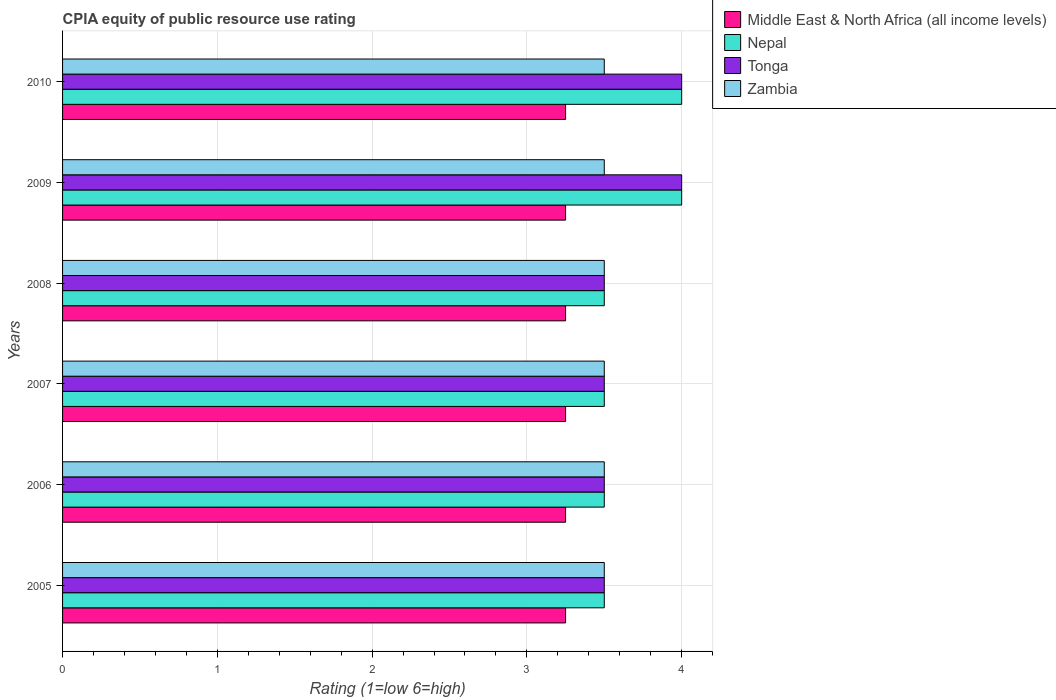How many groups of bars are there?
Provide a short and direct response. 6. Are the number of bars on each tick of the Y-axis equal?
Offer a terse response. Yes. How many bars are there on the 5th tick from the bottom?
Make the answer very short. 4. What is the label of the 3rd group of bars from the top?
Ensure brevity in your answer.  2008. Across all years, what is the minimum CPIA rating in Zambia?
Your answer should be very brief. 3.5. What is the difference between the CPIA rating in Tonga in 2005 and that in 2008?
Provide a succinct answer. 0. What is the difference between the CPIA rating in Tonga in 2005 and the CPIA rating in Zambia in 2007?
Your answer should be very brief. 0. What is the average CPIA rating in Middle East & North Africa (all income levels) per year?
Make the answer very short. 3.25. In how many years, is the CPIA rating in Zambia greater than 0.4 ?
Provide a short and direct response. 6. What is the ratio of the CPIA rating in Zambia in 2005 to that in 2010?
Your answer should be compact. 1. What is the difference between the highest and the lowest CPIA rating in Zambia?
Provide a succinct answer. 0. What does the 1st bar from the top in 2007 represents?
Provide a short and direct response. Zambia. What does the 3rd bar from the bottom in 2010 represents?
Offer a terse response. Tonga. How many bars are there?
Give a very brief answer. 24. Are all the bars in the graph horizontal?
Keep it short and to the point. Yes. What is the difference between two consecutive major ticks on the X-axis?
Your answer should be compact. 1. Does the graph contain grids?
Offer a terse response. Yes. Where does the legend appear in the graph?
Keep it short and to the point. Top right. What is the title of the graph?
Keep it short and to the point. CPIA equity of public resource use rating. What is the label or title of the Y-axis?
Offer a very short reply. Years. What is the Rating (1=low 6=high) in Tonga in 2005?
Provide a succinct answer. 3.5. What is the Rating (1=low 6=high) of Middle East & North Africa (all income levels) in 2006?
Make the answer very short. 3.25. What is the Rating (1=low 6=high) in Tonga in 2006?
Provide a short and direct response. 3.5. What is the Rating (1=low 6=high) in Zambia in 2006?
Your answer should be very brief. 3.5. What is the Rating (1=low 6=high) of Middle East & North Africa (all income levels) in 2007?
Offer a terse response. 3.25. What is the Rating (1=low 6=high) in Nepal in 2007?
Provide a short and direct response. 3.5. What is the Rating (1=low 6=high) in Tonga in 2007?
Provide a short and direct response. 3.5. What is the Rating (1=low 6=high) of Zambia in 2007?
Keep it short and to the point. 3.5. What is the Rating (1=low 6=high) in Middle East & North Africa (all income levels) in 2008?
Your answer should be very brief. 3.25. What is the Rating (1=low 6=high) in Tonga in 2008?
Offer a terse response. 3.5. What is the Rating (1=low 6=high) of Zambia in 2008?
Provide a succinct answer. 3.5. What is the Rating (1=low 6=high) of Zambia in 2009?
Keep it short and to the point. 3.5. Across all years, what is the maximum Rating (1=low 6=high) in Nepal?
Give a very brief answer. 4. Across all years, what is the minimum Rating (1=low 6=high) in Middle East & North Africa (all income levels)?
Offer a terse response. 3.25. What is the total Rating (1=low 6=high) of Nepal in the graph?
Your response must be concise. 22. What is the total Rating (1=low 6=high) of Tonga in the graph?
Your response must be concise. 22. What is the difference between the Rating (1=low 6=high) in Nepal in 2005 and that in 2006?
Provide a short and direct response. 0. What is the difference between the Rating (1=low 6=high) in Tonga in 2005 and that in 2006?
Offer a terse response. 0. What is the difference between the Rating (1=low 6=high) in Middle East & North Africa (all income levels) in 2005 and that in 2007?
Make the answer very short. 0. What is the difference between the Rating (1=low 6=high) of Nepal in 2005 and that in 2007?
Offer a terse response. 0. What is the difference between the Rating (1=low 6=high) in Tonga in 2005 and that in 2007?
Make the answer very short. 0. What is the difference between the Rating (1=low 6=high) of Zambia in 2005 and that in 2007?
Keep it short and to the point. 0. What is the difference between the Rating (1=low 6=high) in Middle East & North Africa (all income levels) in 2005 and that in 2008?
Offer a very short reply. 0. What is the difference between the Rating (1=low 6=high) of Nepal in 2005 and that in 2008?
Your response must be concise. 0. What is the difference between the Rating (1=low 6=high) of Nepal in 2005 and that in 2009?
Your answer should be very brief. -0.5. What is the difference between the Rating (1=low 6=high) of Zambia in 2005 and that in 2009?
Offer a terse response. 0. What is the difference between the Rating (1=low 6=high) of Nepal in 2005 and that in 2010?
Keep it short and to the point. -0.5. What is the difference between the Rating (1=low 6=high) of Middle East & North Africa (all income levels) in 2006 and that in 2007?
Make the answer very short. 0. What is the difference between the Rating (1=low 6=high) of Nepal in 2006 and that in 2007?
Offer a very short reply. 0. What is the difference between the Rating (1=low 6=high) of Tonga in 2006 and that in 2007?
Offer a very short reply. 0. What is the difference between the Rating (1=low 6=high) in Zambia in 2006 and that in 2007?
Offer a very short reply. 0. What is the difference between the Rating (1=low 6=high) in Nepal in 2006 and that in 2008?
Offer a terse response. 0. What is the difference between the Rating (1=low 6=high) in Tonga in 2006 and that in 2008?
Your answer should be very brief. 0. What is the difference between the Rating (1=low 6=high) in Tonga in 2006 and that in 2009?
Provide a succinct answer. -0.5. What is the difference between the Rating (1=low 6=high) in Zambia in 2006 and that in 2009?
Provide a short and direct response. 0. What is the difference between the Rating (1=low 6=high) of Middle East & North Africa (all income levels) in 2006 and that in 2010?
Keep it short and to the point. 0. What is the difference between the Rating (1=low 6=high) of Nepal in 2006 and that in 2010?
Provide a short and direct response. -0.5. What is the difference between the Rating (1=low 6=high) in Tonga in 2006 and that in 2010?
Make the answer very short. -0.5. What is the difference between the Rating (1=low 6=high) of Nepal in 2007 and that in 2008?
Give a very brief answer. 0. What is the difference between the Rating (1=low 6=high) in Tonga in 2007 and that in 2008?
Your answer should be very brief. 0. What is the difference between the Rating (1=low 6=high) in Nepal in 2007 and that in 2009?
Your answer should be very brief. -0.5. What is the difference between the Rating (1=low 6=high) in Nepal in 2007 and that in 2010?
Ensure brevity in your answer.  -0.5. What is the difference between the Rating (1=low 6=high) in Tonga in 2007 and that in 2010?
Your answer should be compact. -0.5. What is the difference between the Rating (1=low 6=high) of Nepal in 2008 and that in 2009?
Keep it short and to the point. -0.5. What is the difference between the Rating (1=low 6=high) of Zambia in 2008 and that in 2009?
Offer a terse response. 0. What is the difference between the Rating (1=low 6=high) of Middle East & North Africa (all income levels) in 2008 and that in 2010?
Keep it short and to the point. 0. What is the difference between the Rating (1=low 6=high) in Zambia in 2008 and that in 2010?
Offer a terse response. 0. What is the difference between the Rating (1=low 6=high) in Nepal in 2009 and that in 2010?
Ensure brevity in your answer.  0. What is the difference between the Rating (1=low 6=high) of Zambia in 2009 and that in 2010?
Keep it short and to the point. 0. What is the difference between the Rating (1=low 6=high) of Middle East & North Africa (all income levels) in 2005 and the Rating (1=low 6=high) of Tonga in 2006?
Give a very brief answer. -0.25. What is the difference between the Rating (1=low 6=high) of Nepal in 2005 and the Rating (1=low 6=high) of Zambia in 2006?
Keep it short and to the point. 0. What is the difference between the Rating (1=low 6=high) in Tonga in 2005 and the Rating (1=low 6=high) in Zambia in 2006?
Provide a succinct answer. 0. What is the difference between the Rating (1=low 6=high) of Middle East & North Africa (all income levels) in 2005 and the Rating (1=low 6=high) of Nepal in 2007?
Provide a short and direct response. -0.25. What is the difference between the Rating (1=low 6=high) of Middle East & North Africa (all income levels) in 2005 and the Rating (1=low 6=high) of Zambia in 2007?
Ensure brevity in your answer.  -0.25. What is the difference between the Rating (1=low 6=high) in Nepal in 2005 and the Rating (1=low 6=high) in Zambia in 2007?
Your response must be concise. 0. What is the difference between the Rating (1=low 6=high) in Tonga in 2005 and the Rating (1=low 6=high) in Zambia in 2007?
Your answer should be compact. 0. What is the difference between the Rating (1=low 6=high) in Middle East & North Africa (all income levels) in 2005 and the Rating (1=low 6=high) in Zambia in 2008?
Give a very brief answer. -0.25. What is the difference between the Rating (1=low 6=high) in Nepal in 2005 and the Rating (1=low 6=high) in Tonga in 2008?
Keep it short and to the point. 0. What is the difference between the Rating (1=low 6=high) of Nepal in 2005 and the Rating (1=low 6=high) of Zambia in 2008?
Your answer should be very brief. 0. What is the difference between the Rating (1=low 6=high) of Middle East & North Africa (all income levels) in 2005 and the Rating (1=low 6=high) of Nepal in 2009?
Offer a terse response. -0.75. What is the difference between the Rating (1=low 6=high) of Middle East & North Africa (all income levels) in 2005 and the Rating (1=low 6=high) of Tonga in 2009?
Provide a succinct answer. -0.75. What is the difference between the Rating (1=low 6=high) of Middle East & North Africa (all income levels) in 2005 and the Rating (1=low 6=high) of Nepal in 2010?
Provide a short and direct response. -0.75. What is the difference between the Rating (1=low 6=high) in Middle East & North Africa (all income levels) in 2005 and the Rating (1=low 6=high) in Tonga in 2010?
Your answer should be very brief. -0.75. What is the difference between the Rating (1=low 6=high) of Middle East & North Africa (all income levels) in 2005 and the Rating (1=low 6=high) of Zambia in 2010?
Ensure brevity in your answer.  -0.25. What is the difference between the Rating (1=low 6=high) of Nepal in 2005 and the Rating (1=low 6=high) of Zambia in 2010?
Provide a succinct answer. 0. What is the difference between the Rating (1=low 6=high) in Middle East & North Africa (all income levels) in 2006 and the Rating (1=low 6=high) in Tonga in 2007?
Your answer should be very brief. -0.25. What is the difference between the Rating (1=low 6=high) in Middle East & North Africa (all income levels) in 2006 and the Rating (1=low 6=high) in Nepal in 2008?
Offer a very short reply. -0.25. What is the difference between the Rating (1=low 6=high) in Middle East & North Africa (all income levels) in 2006 and the Rating (1=low 6=high) in Tonga in 2008?
Your response must be concise. -0.25. What is the difference between the Rating (1=low 6=high) in Tonga in 2006 and the Rating (1=low 6=high) in Zambia in 2008?
Provide a succinct answer. 0. What is the difference between the Rating (1=low 6=high) in Middle East & North Africa (all income levels) in 2006 and the Rating (1=low 6=high) in Nepal in 2009?
Ensure brevity in your answer.  -0.75. What is the difference between the Rating (1=low 6=high) in Middle East & North Africa (all income levels) in 2006 and the Rating (1=low 6=high) in Tonga in 2009?
Your answer should be very brief. -0.75. What is the difference between the Rating (1=low 6=high) in Nepal in 2006 and the Rating (1=low 6=high) in Tonga in 2009?
Keep it short and to the point. -0.5. What is the difference between the Rating (1=low 6=high) in Tonga in 2006 and the Rating (1=low 6=high) in Zambia in 2009?
Provide a short and direct response. 0. What is the difference between the Rating (1=low 6=high) of Middle East & North Africa (all income levels) in 2006 and the Rating (1=low 6=high) of Nepal in 2010?
Provide a short and direct response. -0.75. What is the difference between the Rating (1=low 6=high) of Middle East & North Africa (all income levels) in 2006 and the Rating (1=low 6=high) of Tonga in 2010?
Your response must be concise. -0.75. What is the difference between the Rating (1=low 6=high) of Middle East & North Africa (all income levels) in 2006 and the Rating (1=low 6=high) of Zambia in 2010?
Make the answer very short. -0.25. What is the difference between the Rating (1=low 6=high) of Nepal in 2006 and the Rating (1=low 6=high) of Tonga in 2010?
Offer a very short reply. -0.5. What is the difference between the Rating (1=low 6=high) of Nepal in 2006 and the Rating (1=low 6=high) of Zambia in 2010?
Make the answer very short. 0. What is the difference between the Rating (1=low 6=high) of Middle East & North Africa (all income levels) in 2007 and the Rating (1=low 6=high) of Tonga in 2008?
Offer a very short reply. -0.25. What is the difference between the Rating (1=low 6=high) in Nepal in 2007 and the Rating (1=low 6=high) in Tonga in 2008?
Your response must be concise. 0. What is the difference between the Rating (1=low 6=high) of Middle East & North Africa (all income levels) in 2007 and the Rating (1=low 6=high) of Nepal in 2009?
Provide a succinct answer. -0.75. What is the difference between the Rating (1=low 6=high) of Middle East & North Africa (all income levels) in 2007 and the Rating (1=low 6=high) of Tonga in 2009?
Keep it short and to the point. -0.75. What is the difference between the Rating (1=low 6=high) in Middle East & North Africa (all income levels) in 2007 and the Rating (1=low 6=high) in Nepal in 2010?
Offer a terse response. -0.75. What is the difference between the Rating (1=low 6=high) in Middle East & North Africa (all income levels) in 2007 and the Rating (1=low 6=high) in Tonga in 2010?
Give a very brief answer. -0.75. What is the difference between the Rating (1=low 6=high) of Middle East & North Africa (all income levels) in 2008 and the Rating (1=low 6=high) of Nepal in 2009?
Give a very brief answer. -0.75. What is the difference between the Rating (1=low 6=high) in Middle East & North Africa (all income levels) in 2008 and the Rating (1=low 6=high) in Tonga in 2009?
Your answer should be compact. -0.75. What is the difference between the Rating (1=low 6=high) in Middle East & North Africa (all income levels) in 2008 and the Rating (1=low 6=high) in Nepal in 2010?
Provide a succinct answer. -0.75. What is the difference between the Rating (1=low 6=high) of Middle East & North Africa (all income levels) in 2008 and the Rating (1=low 6=high) of Tonga in 2010?
Your answer should be very brief. -0.75. What is the difference between the Rating (1=low 6=high) in Middle East & North Africa (all income levels) in 2008 and the Rating (1=low 6=high) in Zambia in 2010?
Ensure brevity in your answer.  -0.25. What is the difference between the Rating (1=low 6=high) of Nepal in 2008 and the Rating (1=low 6=high) of Tonga in 2010?
Provide a short and direct response. -0.5. What is the difference between the Rating (1=low 6=high) in Middle East & North Africa (all income levels) in 2009 and the Rating (1=low 6=high) in Nepal in 2010?
Your answer should be very brief. -0.75. What is the difference between the Rating (1=low 6=high) in Middle East & North Africa (all income levels) in 2009 and the Rating (1=low 6=high) in Tonga in 2010?
Your response must be concise. -0.75. What is the difference between the Rating (1=low 6=high) in Middle East & North Africa (all income levels) in 2009 and the Rating (1=low 6=high) in Zambia in 2010?
Your response must be concise. -0.25. What is the difference between the Rating (1=low 6=high) in Tonga in 2009 and the Rating (1=low 6=high) in Zambia in 2010?
Ensure brevity in your answer.  0.5. What is the average Rating (1=low 6=high) in Nepal per year?
Give a very brief answer. 3.67. What is the average Rating (1=low 6=high) in Tonga per year?
Provide a succinct answer. 3.67. What is the average Rating (1=low 6=high) of Zambia per year?
Ensure brevity in your answer.  3.5. In the year 2005, what is the difference between the Rating (1=low 6=high) in Middle East & North Africa (all income levels) and Rating (1=low 6=high) in Zambia?
Provide a short and direct response. -0.25. In the year 2006, what is the difference between the Rating (1=low 6=high) of Tonga and Rating (1=low 6=high) of Zambia?
Offer a terse response. 0. In the year 2007, what is the difference between the Rating (1=low 6=high) of Tonga and Rating (1=low 6=high) of Zambia?
Ensure brevity in your answer.  0. In the year 2008, what is the difference between the Rating (1=low 6=high) in Middle East & North Africa (all income levels) and Rating (1=low 6=high) in Nepal?
Make the answer very short. -0.25. In the year 2008, what is the difference between the Rating (1=low 6=high) in Middle East & North Africa (all income levels) and Rating (1=low 6=high) in Tonga?
Give a very brief answer. -0.25. In the year 2008, what is the difference between the Rating (1=low 6=high) of Tonga and Rating (1=low 6=high) of Zambia?
Keep it short and to the point. 0. In the year 2009, what is the difference between the Rating (1=low 6=high) in Middle East & North Africa (all income levels) and Rating (1=low 6=high) in Nepal?
Ensure brevity in your answer.  -0.75. In the year 2009, what is the difference between the Rating (1=low 6=high) of Middle East & North Africa (all income levels) and Rating (1=low 6=high) of Tonga?
Your response must be concise. -0.75. In the year 2009, what is the difference between the Rating (1=low 6=high) of Middle East & North Africa (all income levels) and Rating (1=low 6=high) of Zambia?
Your answer should be very brief. -0.25. In the year 2009, what is the difference between the Rating (1=low 6=high) of Nepal and Rating (1=low 6=high) of Tonga?
Provide a succinct answer. 0. In the year 2009, what is the difference between the Rating (1=low 6=high) of Nepal and Rating (1=low 6=high) of Zambia?
Offer a very short reply. 0.5. In the year 2009, what is the difference between the Rating (1=low 6=high) of Tonga and Rating (1=low 6=high) of Zambia?
Provide a short and direct response. 0.5. In the year 2010, what is the difference between the Rating (1=low 6=high) in Middle East & North Africa (all income levels) and Rating (1=low 6=high) in Nepal?
Offer a very short reply. -0.75. In the year 2010, what is the difference between the Rating (1=low 6=high) of Middle East & North Africa (all income levels) and Rating (1=low 6=high) of Tonga?
Give a very brief answer. -0.75. In the year 2010, what is the difference between the Rating (1=low 6=high) in Nepal and Rating (1=low 6=high) in Tonga?
Ensure brevity in your answer.  0. In the year 2010, what is the difference between the Rating (1=low 6=high) in Nepal and Rating (1=low 6=high) in Zambia?
Ensure brevity in your answer.  0.5. What is the ratio of the Rating (1=low 6=high) of Middle East & North Africa (all income levels) in 2005 to that in 2006?
Your response must be concise. 1. What is the ratio of the Rating (1=low 6=high) of Middle East & North Africa (all income levels) in 2005 to that in 2007?
Your answer should be very brief. 1. What is the ratio of the Rating (1=low 6=high) in Nepal in 2005 to that in 2007?
Ensure brevity in your answer.  1. What is the ratio of the Rating (1=low 6=high) of Tonga in 2005 to that in 2007?
Ensure brevity in your answer.  1. What is the ratio of the Rating (1=low 6=high) in Zambia in 2005 to that in 2007?
Your response must be concise. 1. What is the ratio of the Rating (1=low 6=high) in Nepal in 2005 to that in 2008?
Provide a short and direct response. 1. What is the ratio of the Rating (1=low 6=high) of Tonga in 2005 to that in 2008?
Provide a short and direct response. 1. What is the ratio of the Rating (1=low 6=high) of Middle East & North Africa (all income levels) in 2005 to that in 2009?
Provide a succinct answer. 1. What is the ratio of the Rating (1=low 6=high) in Nepal in 2005 to that in 2009?
Your answer should be very brief. 0.88. What is the ratio of the Rating (1=low 6=high) in Tonga in 2005 to that in 2010?
Provide a succinct answer. 0.88. What is the ratio of the Rating (1=low 6=high) in Zambia in 2005 to that in 2010?
Your answer should be compact. 1. What is the ratio of the Rating (1=low 6=high) of Middle East & North Africa (all income levels) in 2006 to that in 2007?
Your answer should be very brief. 1. What is the ratio of the Rating (1=low 6=high) in Nepal in 2006 to that in 2007?
Ensure brevity in your answer.  1. What is the ratio of the Rating (1=low 6=high) of Middle East & North Africa (all income levels) in 2006 to that in 2008?
Offer a terse response. 1. What is the ratio of the Rating (1=low 6=high) in Nepal in 2006 to that in 2008?
Your answer should be very brief. 1. What is the ratio of the Rating (1=low 6=high) of Middle East & North Africa (all income levels) in 2006 to that in 2009?
Offer a terse response. 1. What is the ratio of the Rating (1=low 6=high) in Zambia in 2006 to that in 2009?
Offer a terse response. 1. What is the ratio of the Rating (1=low 6=high) in Zambia in 2006 to that in 2010?
Your answer should be very brief. 1. What is the ratio of the Rating (1=low 6=high) in Middle East & North Africa (all income levels) in 2007 to that in 2008?
Make the answer very short. 1. What is the ratio of the Rating (1=low 6=high) of Tonga in 2007 to that in 2008?
Offer a very short reply. 1. What is the ratio of the Rating (1=low 6=high) in Nepal in 2007 to that in 2009?
Keep it short and to the point. 0.88. What is the ratio of the Rating (1=low 6=high) of Tonga in 2007 to that in 2009?
Offer a terse response. 0.88. What is the ratio of the Rating (1=low 6=high) in Middle East & North Africa (all income levels) in 2007 to that in 2010?
Give a very brief answer. 1. What is the ratio of the Rating (1=low 6=high) of Nepal in 2007 to that in 2010?
Keep it short and to the point. 0.88. What is the ratio of the Rating (1=low 6=high) in Zambia in 2007 to that in 2010?
Your response must be concise. 1. What is the ratio of the Rating (1=low 6=high) of Middle East & North Africa (all income levels) in 2008 to that in 2009?
Ensure brevity in your answer.  1. What is the ratio of the Rating (1=low 6=high) in Tonga in 2008 to that in 2009?
Keep it short and to the point. 0.88. What is the ratio of the Rating (1=low 6=high) in Nepal in 2008 to that in 2010?
Make the answer very short. 0.88. What is the ratio of the Rating (1=low 6=high) in Nepal in 2009 to that in 2010?
Offer a terse response. 1. What is the ratio of the Rating (1=low 6=high) of Tonga in 2009 to that in 2010?
Offer a terse response. 1. What is the ratio of the Rating (1=low 6=high) of Zambia in 2009 to that in 2010?
Offer a very short reply. 1. What is the difference between the highest and the second highest Rating (1=low 6=high) of Tonga?
Provide a succinct answer. 0. What is the difference between the highest and the lowest Rating (1=low 6=high) in Middle East & North Africa (all income levels)?
Your response must be concise. 0. What is the difference between the highest and the lowest Rating (1=low 6=high) in Nepal?
Offer a terse response. 0.5. What is the difference between the highest and the lowest Rating (1=low 6=high) in Zambia?
Your response must be concise. 0. 